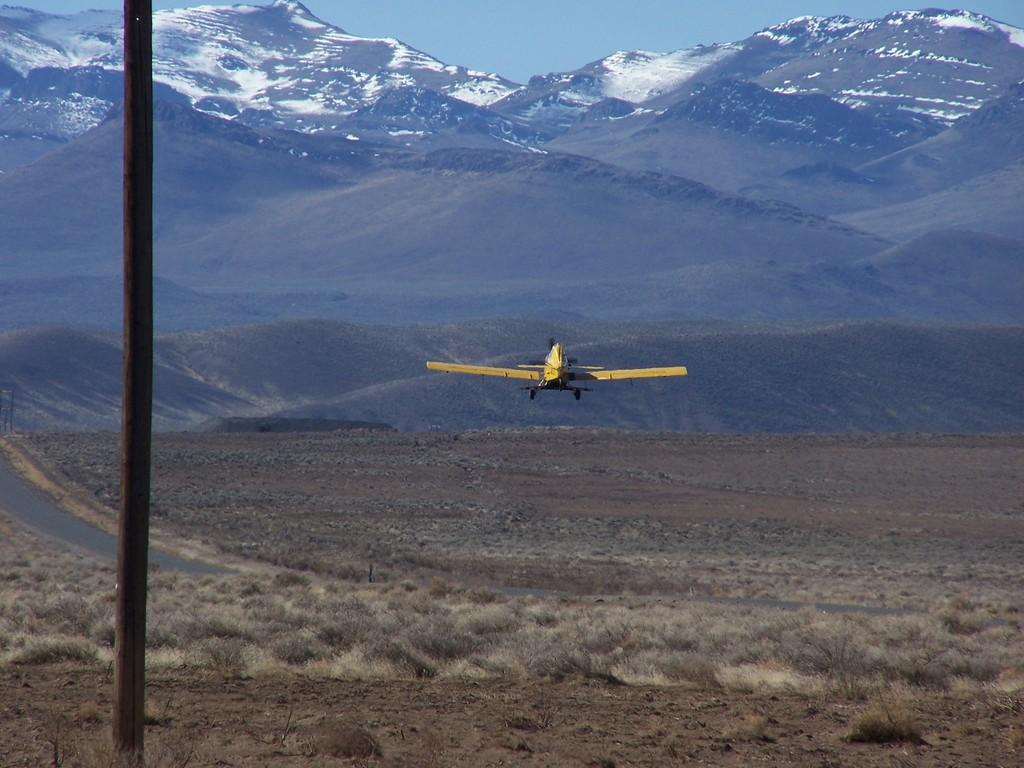What type of aircraft is flying in the image? There is a yellow color aircraft flying in the image. What can be seen on the left side of the image? There is a road on the left side of the image. What object is present in the image that is typically used for supporting or holding something? There is a pole in the image. What type of vegetation is present on the ground in the image? There are plants on the ground in the image. What natural features can be seen in the background of the image? There are mountains in the background of the image. What is visible in the sky in the background of the image? The sky is visible in the background of the image. What type of cake is being served during the recess in the image? There is no cake or recess present in the image. 